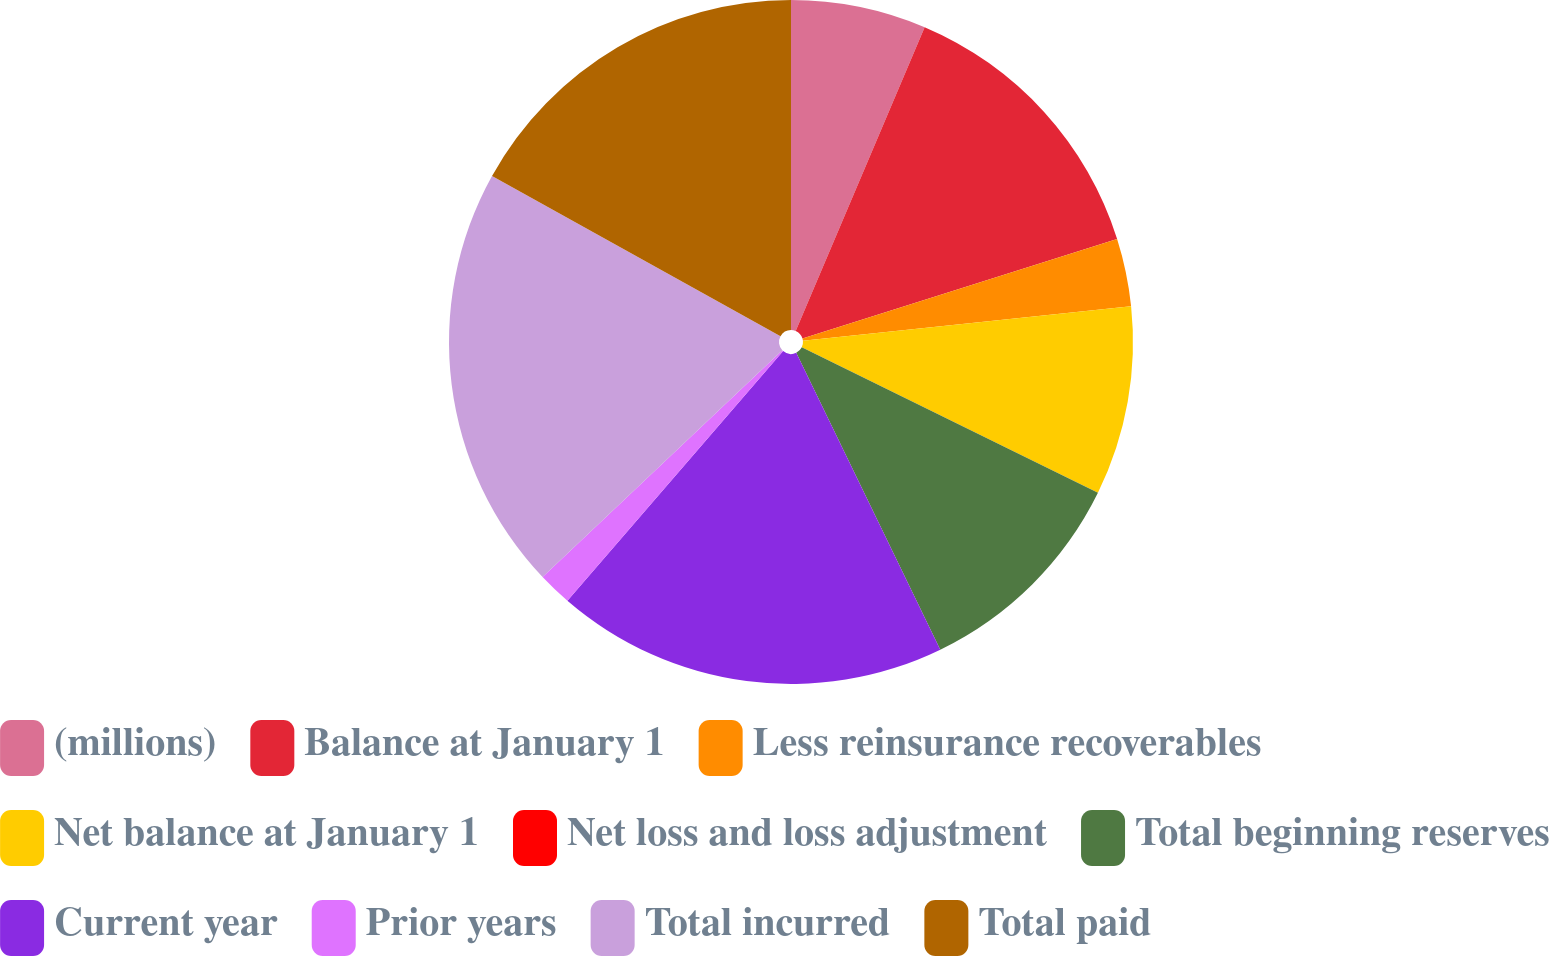Convert chart. <chart><loc_0><loc_0><loc_500><loc_500><pie_chart><fcel>(millions)<fcel>Balance at January 1<fcel>Less reinsurance recoverables<fcel>Net balance at January 1<fcel>Net loss and loss adjustment<fcel>Total beginning reserves<fcel>Current year<fcel>Prior years<fcel>Total incurred<fcel>Total paid<nl><fcel>6.39%<fcel>13.74%<fcel>3.2%<fcel>8.94%<fcel>0.0%<fcel>10.54%<fcel>18.53%<fcel>1.6%<fcel>20.13%<fcel>16.93%<nl></chart> 